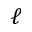<formula> <loc_0><loc_0><loc_500><loc_500>\ell</formula> 